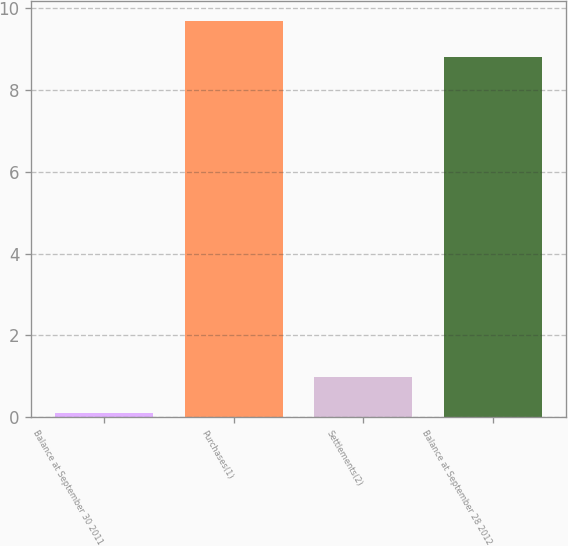Convert chart to OTSL. <chart><loc_0><loc_0><loc_500><loc_500><bar_chart><fcel>Balance at September 30 2011<fcel>Purchases(1)<fcel>Settlements(2)<fcel>Balance at September 28 2012<nl><fcel>0.1<fcel>9.69<fcel>0.99<fcel>8.8<nl></chart> 